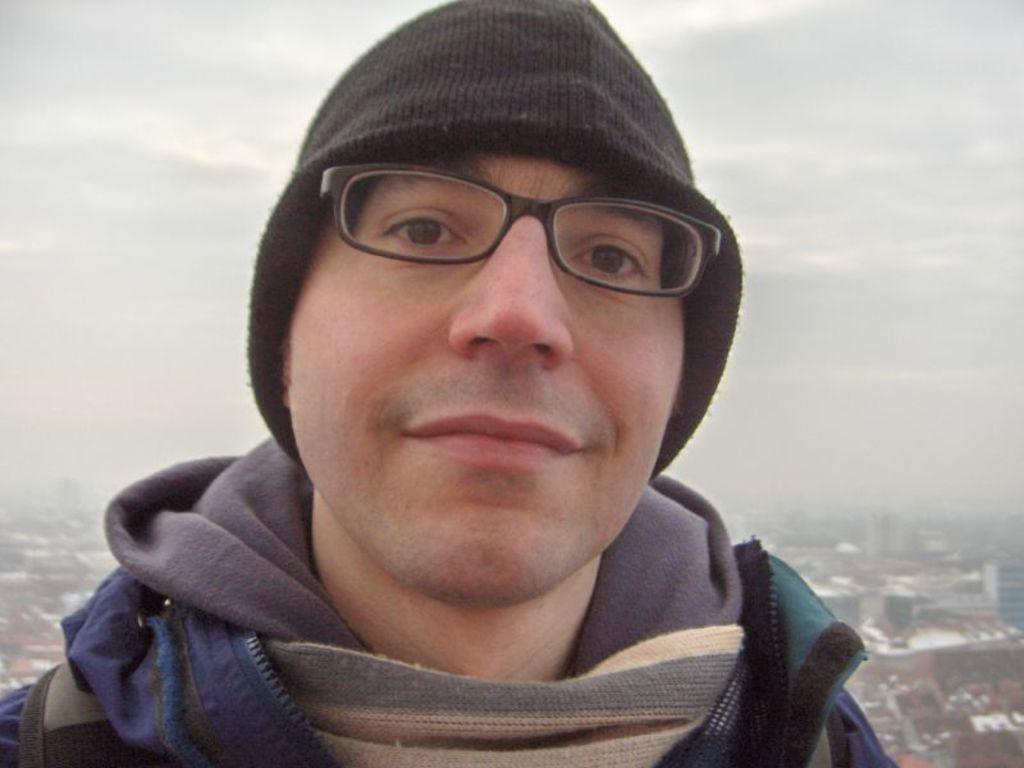Who is present in the image? There is a man in the image. What is the man wearing on his head? The man is wearing a cap. What type of eyewear is the man wearing? The man is wearing spectacles. What type of clothing is the man wearing on his upper body? The man is wearing a jacket. What can be seen in the background of the image? There are buildings in the background of the image. What is visible at the top of the image? The sky is visible at the top of the image. What type of cream is being discussed by the dogs in the image? There are no dogs present in the image, and therefore no discussion about cream can be observed. 